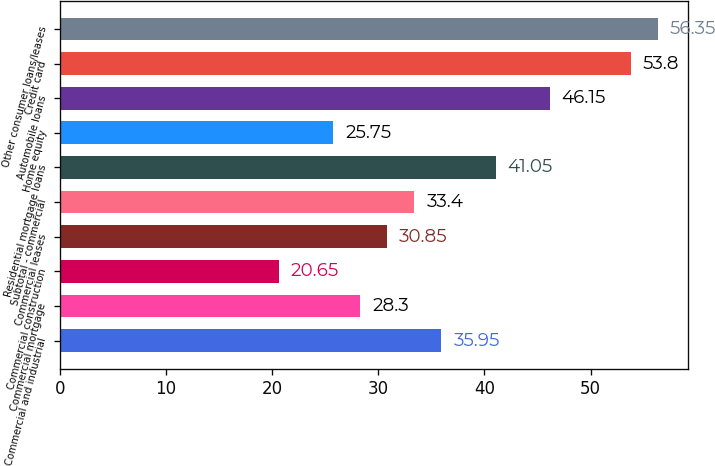Convert chart. <chart><loc_0><loc_0><loc_500><loc_500><bar_chart><fcel>Commercial and industrial<fcel>Commercial mortgage<fcel>Commercial construction<fcel>Commercial leases<fcel>Subtotal - commercial<fcel>Residential mortgage loans<fcel>Home equity<fcel>Automobile loans<fcel>Credit card<fcel>Other consumer loans/leases<nl><fcel>35.95<fcel>28.3<fcel>20.65<fcel>30.85<fcel>33.4<fcel>41.05<fcel>25.75<fcel>46.15<fcel>53.8<fcel>56.35<nl></chart> 